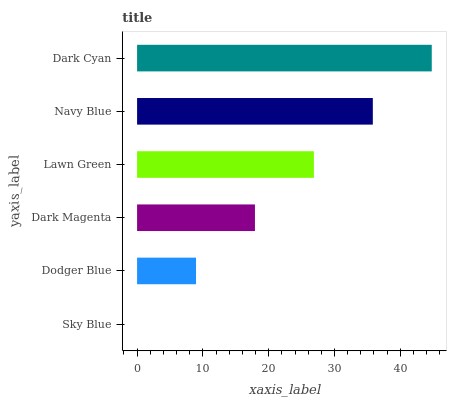Is Sky Blue the minimum?
Answer yes or no. Yes. Is Dark Cyan the maximum?
Answer yes or no. Yes. Is Dodger Blue the minimum?
Answer yes or no. No. Is Dodger Blue the maximum?
Answer yes or no. No. Is Dodger Blue greater than Sky Blue?
Answer yes or no. Yes. Is Sky Blue less than Dodger Blue?
Answer yes or no. Yes. Is Sky Blue greater than Dodger Blue?
Answer yes or no. No. Is Dodger Blue less than Sky Blue?
Answer yes or no. No. Is Lawn Green the high median?
Answer yes or no. Yes. Is Dark Magenta the low median?
Answer yes or no. Yes. Is Dark Cyan the high median?
Answer yes or no. No. Is Navy Blue the low median?
Answer yes or no. No. 